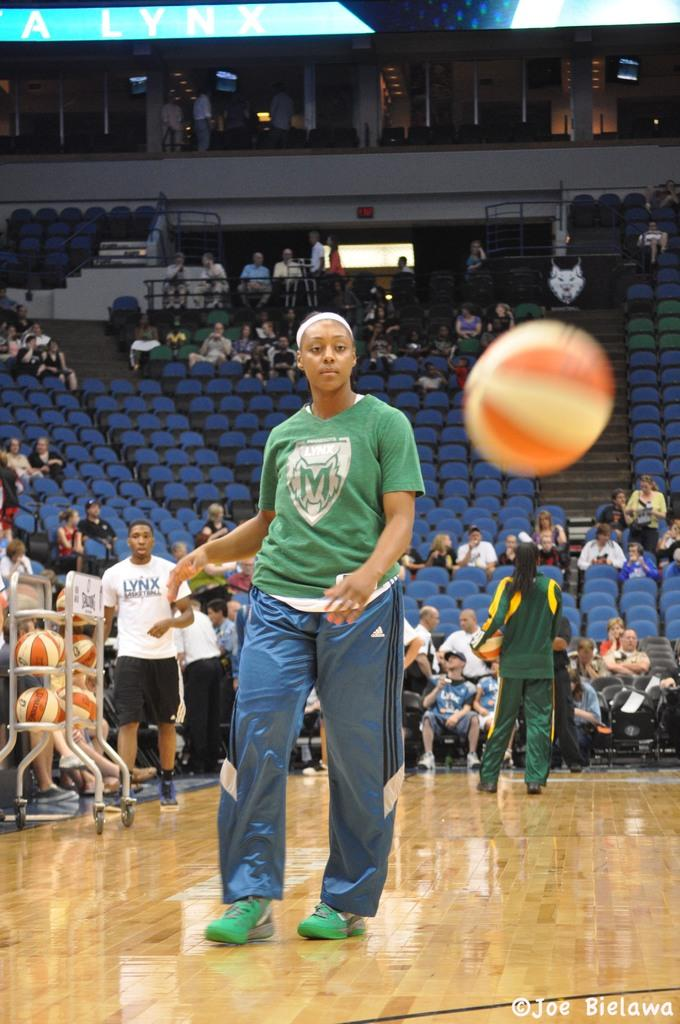What is in the air in the image? There is a ball in the air in the image. What are the people on the ground doing? The people on the ground are not specified in the facts, so we cannot determine their actions. What are the people sitting on in the image? There are people sitting on chairs in the image. What can be seen in the background of the image? In the background of the image, there are rods, walls, and some objects visible. What type of leather is being used to make the letters in the image? There are no letters or leather present in the image. What is the copper content of the objects in the background of the image? There is no information about the materials or composition of the objects in the background of the image. 